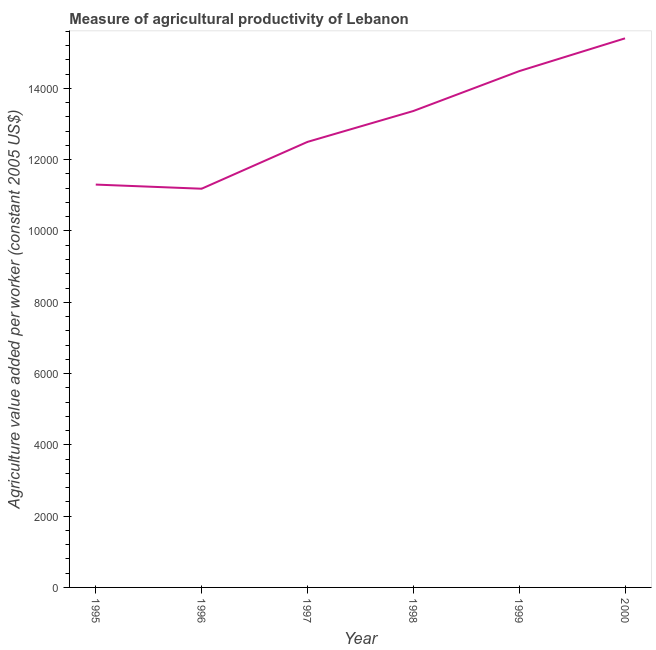What is the agriculture value added per worker in 1995?
Offer a very short reply. 1.13e+04. Across all years, what is the maximum agriculture value added per worker?
Your response must be concise. 1.54e+04. Across all years, what is the minimum agriculture value added per worker?
Offer a terse response. 1.12e+04. In which year was the agriculture value added per worker maximum?
Ensure brevity in your answer.  2000. What is the sum of the agriculture value added per worker?
Give a very brief answer. 7.82e+04. What is the difference between the agriculture value added per worker in 1997 and 1998?
Your response must be concise. -866.49. What is the average agriculture value added per worker per year?
Make the answer very short. 1.30e+04. What is the median agriculture value added per worker?
Give a very brief answer. 1.29e+04. Do a majority of the years between 1999 and 2000 (inclusive) have agriculture value added per worker greater than 12000 US$?
Give a very brief answer. Yes. What is the ratio of the agriculture value added per worker in 1999 to that in 2000?
Keep it short and to the point. 0.94. Is the agriculture value added per worker in 1998 less than that in 1999?
Make the answer very short. Yes. What is the difference between the highest and the second highest agriculture value added per worker?
Provide a succinct answer. 920.3. What is the difference between the highest and the lowest agriculture value added per worker?
Offer a terse response. 4218.71. In how many years, is the agriculture value added per worker greater than the average agriculture value added per worker taken over all years?
Your answer should be very brief. 3. How many lines are there?
Your answer should be compact. 1. What is the difference between two consecutive major ticks on the Y-axis?
Your answer should be very brief. 2000. Does the graph contain grids?
Your answer should be compact. No. What is the title of the graph?
Give a very brief answer. Measure of agricultural productivity of Lebanon. What is the label or title of the Y-axis?
Your answer should be compact. Agriculture value added per worker (constant 2005 US$). What is the Agriculture value added per worker (constant 2005 US$) of 1995?
Keep it short and to the point. 1.13e+04. What is the Agriculture value added per worker (constant 2005 US$) of 1996?
Your response must be concise. 1.12e+04. What is the Agriculture value added per worker (constant 2005 US$) of 1997?
Offer a very short reply. 1.25e+04. What is the Agriculture value added per worker (constant 2005 US$) of 1998?
Offer a terse response. 1.34e+04. What is the Agriculture value added per worker (constant 2005 US$) in 1999?
Your answer should be compact. 1.45e+04. What is the Agriculture value added per worker (constant 2005 US$) in 2000?
Ensure brevity in your answer.  1.54e+04. What is the difference between the Agriculture value added per worker (constant 2005 US$) in 1995 and 1996?
Provide a succinct answer. 116.47. What is the difference between the Agriculture value added per worker (constant 2005 US$) in 1995 and 1997?
Ensure brevity in your answer.  -1197.06. What is the difference between the Agriculture value added per worker (constant 2005 US$) in 1995 and 1998?
Provide a short and direct response. -2063.55. What is the difference between the Agriculture value added per worker (constant 2005 US$) in 1995 and 1999?
Make the answer very short. -3181.94. What is the difference between the Agriculture value added per worker (constant 2005 US$) in 1995 and 2000?
Ensure brevity in your answer.  -4102.25. What is the difference between the Agriculture value added per worker (constant 2005 US$) in 1996 and 1997?
Provide a succinct answer. -1313.53. What is the difference between the Agriculture value added per worker (constant 2005 US$) in 1996 and 1998?
Give a very brief answer. -2180.02. What is the difference between the Agriculture value added per worker (constant 2005 US$) in 1996 and 1999?
Make the answer very short. -3298.41. What is the difference between the Agriculture value added per worker (constant 2005 US$) in 1996 and 2000?
Your answer should be compact. -4218.71. What is the difference between the Agriculture value added per worker (constant 2005 US$) in 1997 and 1998?
Keep it short and to the point. -866.49. What is the difference between the Agriculture value added per worker (constant 2005 US$) in 1997 and 1999?
Keep it short and to the point. -1984.88. What is the difference between the Agriculture value added per worker (constant 2005 US$) in 1997 and 2000?
Give a very brief answer. -2905.18. What is the difference between the Agriculture value added per worker (constant 2005 US$) in 1998 and 1999?
Offer a very short reply. -1118.39. What is the difference between the Agriculture value added per worker (constant 2005 US$) in 1998 and 2000?
Make the answer very short. -2038.69. What is the difference between the Agriculture value added per worker (constant 2005 US$) in 1999 and 2000?
Provide a short and direct response. -920.3. What is the ratio of the Agriculture value added per worker (constant 2005 US$) in 1995 to that in 1997?
Provide a short and direct response. 0.9. What is the ratio of the Agriculture value added per worker (constant 2005 US$) in 1995 to that in 1998?
Provide a short and direct response. 0.85. What is the ratio of the Agriculture value added per worker (constant 2005 US$) in 1995 to that in 1999?
Provide a short and direct response. 0.78. What is the ratio of the Agriculture value added per worker (constant 2005 US$) in 1995 to that in 2000?
Give a very brief answer. 0.73. What is the ratio of the Agriculture value added per worker (constant 2005 US$) in 1996 to that in 1997?
Provide a short and direct response. 0.9. What is the ratio of the Agriculture value added per worker (constant 2005 US$) in 1996 to that in 1998?
Offer a very short reply. 0.84. What is the ratio of the Agriculture value added per worker (constant 2005 US$) in 1996 to that in 1999?
Provide a succinct answer. 0.77. What is the ratio of the Agriculture value added per worker (constant 2005 US$) in 1996 to that in 2000?
Your answer should be compact. 0.73. What is the ratio of the Agriculture value added per worker (constant 2005 US$) in 1997 to that in 1998?
Your response must be concise. 0.94. What is the ratio of the Agriculture value added per worker (constant 2005 US$) in 1997 to that in 1999?
Your answer should be compact. 0.86. What is the ratio of the Agriculture value added per worker (constant 2005 US$) in 1997 to that in 2000?
Your answer should be compact. 0.81. What is the ratio of the Agriculture value added per worker (constant 2005 US$) in 1998 to that in 1999?
Provide a short and direct response. 0.92. What is the ratio of the Agriculture value added per worker (constant 2005 US$) in 1998 to that in 2000?
Offer a very short reply. 0.87. 